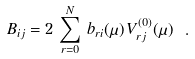Convert formula to latex. <formula><loc_0><loc_0><loc_500><loc_500>B _ { i j } = 2 \, \sum _ { r = 0 } ^ { N } \, b _ { r i } ( \mu ) \, V ^ { ( 0 ) } _ { r j } ( \mu ) \ .</formula> 